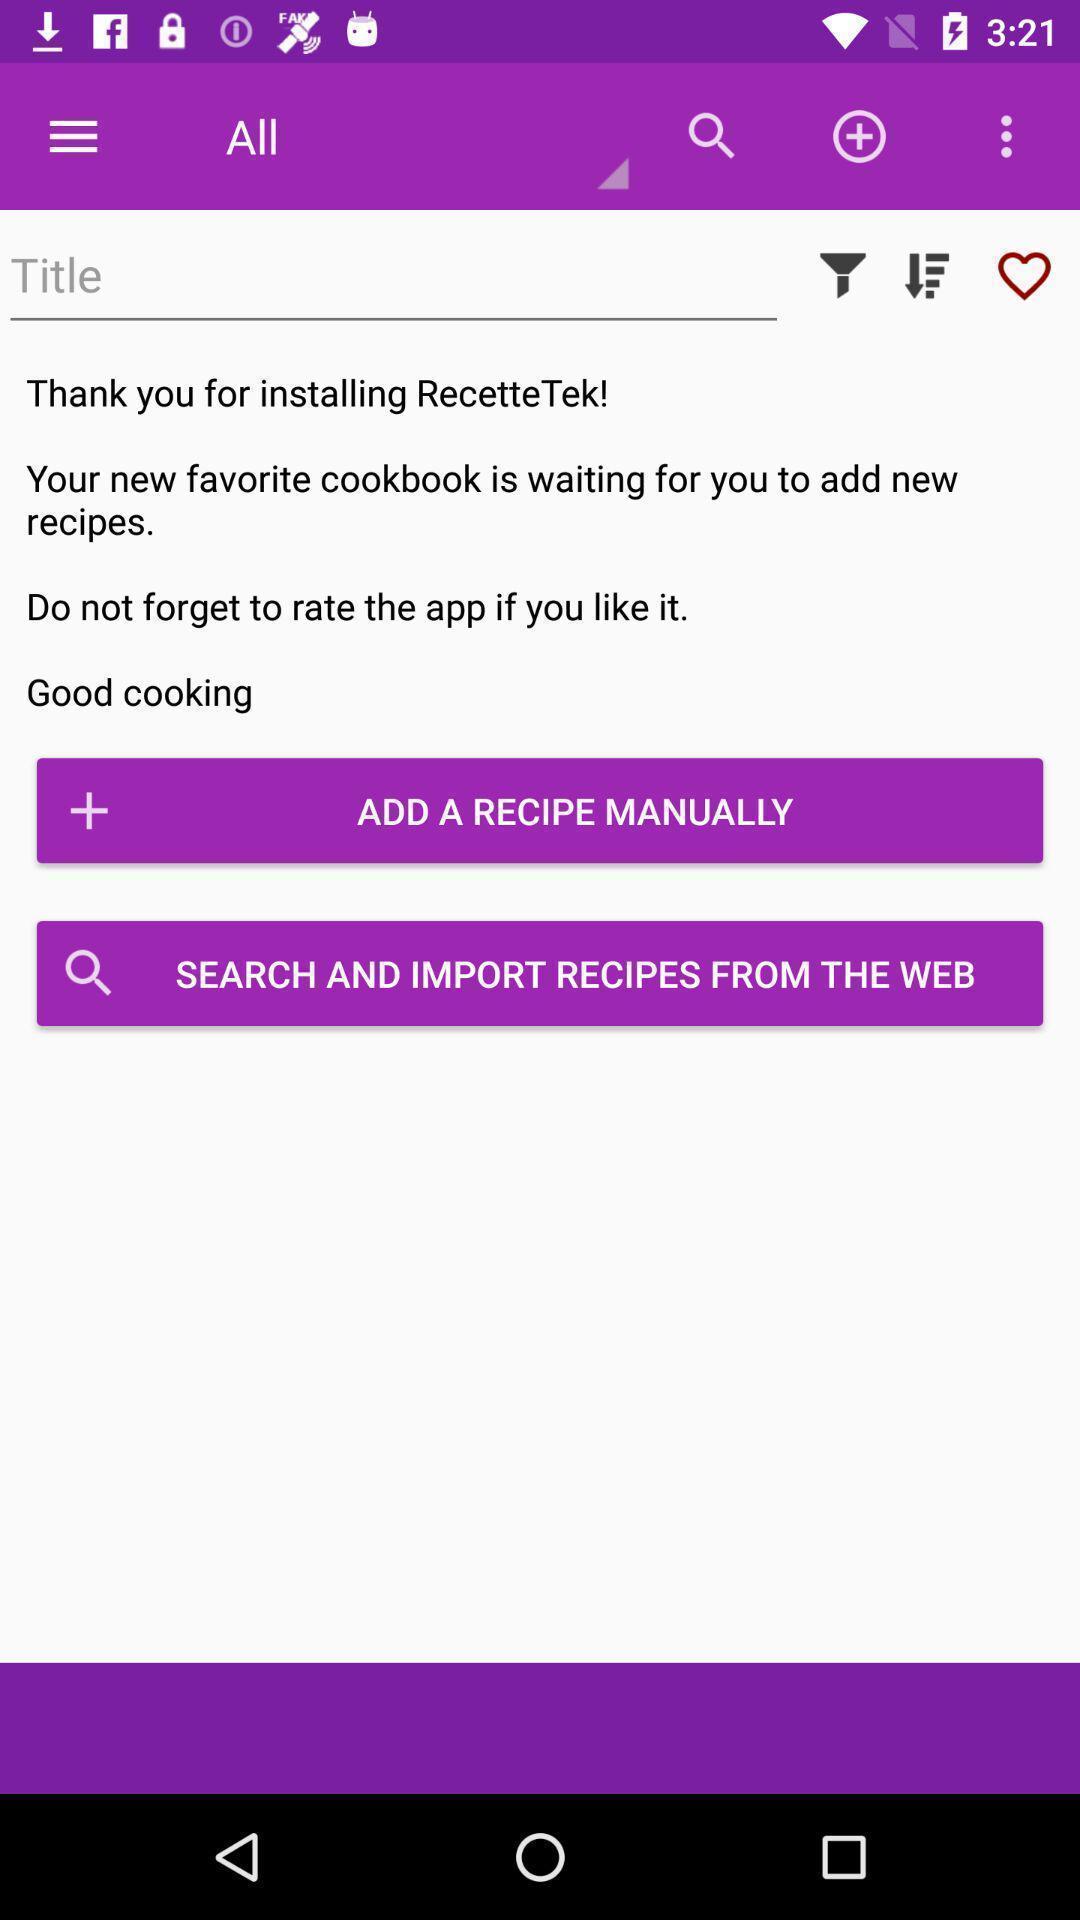Tell me about the visual elements in this screen capture. Window displaying a recipe app. 